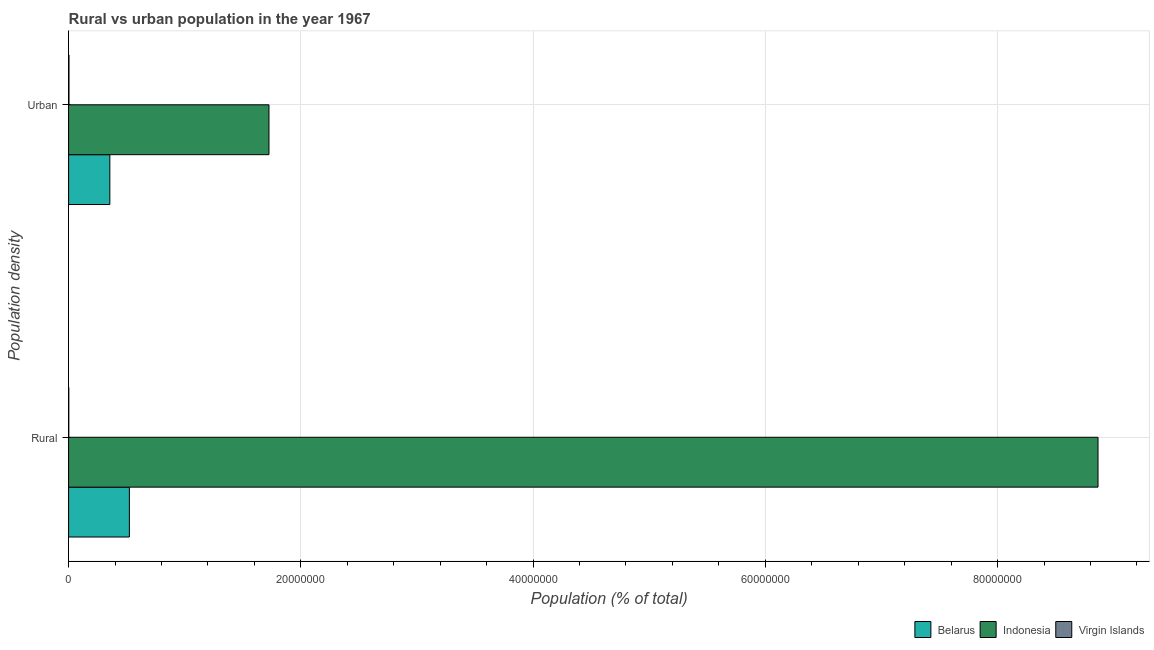How many groups of bars are there?
Keep it short and to the point. 2. Are the number of bars on each tick of the Y-axis equal?
Your answer should be compact. Yes. How many bars are there on the 1st tick from the top?
Provide a short and direct response. 3. What is the label of the 1st group of bars from the top?
Give a very brief answer. Urban. What is the rural population density in Belarus?
Offer a very short reply. 5.23e+06. Across all countries, what is the maximum rural population density?
Offer a very short reply. 8.87e+07. Across all countries, what is the minimum urban population density?
Make the answer very short. 3.35e+04. In which country was the urban population density maximum?
Give a very brief answer. Indonesia. In which country was the rural population density minimum?
Your response must be concise. Virgin Islands. What is the total urban population density in the graph?
Make the answer very short. 2.08e+07. What is the difference between the rural population density in Virgin Islands and that in Indonesia?
Make the answer very short. -8.86e+07. What is the difference between the rural population density in Virgin Islands and the urban population density in Belarus?
Your answer should be very brief. -3.53e+06. What is the average urban population density per country?
Your answer should be compact. 6.95e+06. What is the difference between the urban population density and rural population density in Indonesia?
Offer a terse response. -7.14e+07. In how many countries, is the urban population density greater than 8000000 %?
Provide a succinct answer. 1. What is the ratio of the rural population density in Indonesia to that in Belarus?
Give a very brief answer. 16.94. In how many countries, is the urban population density greater than the average urban population density taken over all countries?
Keep it short and to the point. 1. What does the 1st bar from the top in Rural represents?
Offer a very short reply. Virgin Islands. What does the 2nd bar from the bottom in Urban represents?
Give a very brief answer. Indonesia. Does the graph contain grids?
Offer a very short reply. Yes. How many legend labels are there?
Your answer should be very brief. 3. How are the legend labels stacked?
Give a very brief answer. Horizontal. What is the title of the graph?
Your response must be concise. Rural vs urban population in the year 1967. Does "Eritrea" appear as one of the legend labels in the graph?
Your response must be concise. No. What is the label or title of the X-axis?
Offer a terse response. Population (% of total). What is the label or title of the Y-axis?
Give a very brief answer. Population density. What is the Population (% of total) of Belarus in Rural?
Your response must be concise. 5.23e+06. What is the Population (% of total) of Indonesia in Rural?
Give a very brief answer. 8.87e+07. What is the Population (% of total) of Virgin Islands in Rural?
Provide a short and direct response. 1.73e+04. What is the Population (% of total) of Belarus in Urban?
Keep it short and to the point. 3.55e+06. What is the Population (% of total) in Indonesia in Urban?
Offer a terse response. 1.73e+07. What is the Population (% of total) in Virgin Islands in Urban?
Offer a very short reply. 3.35e+04. Across all Population density, what is the maximum Population (% of total) of Belarus?
Make the answer very short. 5.23e+06. Across all Population density, what is the maximum Population (% of total) of Indonesia?
Your answer should be very brief. 8.87e+07. Across all Population density, what is the maximum Population (% of total) of Virgin Islands?
Provide a succinct answer. 3.35e+04. Across all Population density, what is the minimum Population (% of total) of Belarus?
Provide a short and direct response. 3.55e+06. Across all Population density, what is the minimum Population (% of total) in Indonesia?
Your answer should be compact. 1.73e+07. Across all Population density, what is the minimum Population (% of total) of Virgin Islands?
Provide a succinct answer. 1.73e+04. What is the total Population (% of total) in Belarus in the graph?
Your answer should be very brief. 8.79e+06. What is the total Population (% of total) in Indonesia in the graph?
Your answer should be very brief. 1.06e+08. What is the total Population (% of total) in Virgin Islands in the graph?
Your answer should be compact. 5.08e+04. What is the difference between the Population (% of total) in Belarus in Rural and that in Urban?
Your answer should be very brief. 1.68e+06. What is the difference between the Population (% of total) of Indonesia in Rural and that in Urban?
Your answer should be compact. 7.14e+07. What is the difference between the Population (% of total) of Virgin Islands in Rural and that in Urban?
Make the answer very short. -1.61e+04. What is the difference between the Population (% of total) in Belarus in Rural and the Population (% of total) in Indonesia in Urban?
Give a very brief answer. -1.20e+07. What is the difference between the Population (% of total) of Belarus in Rural and the Population (% of total) of Virgin Islands in Urban?
Your answer should be compact. 5.20e+06. What is the difference between the Population (% of total) in Indonesia in Rural and the Population (% of total) in Virgin Islands in Urban?
Make the answer very short. 8.86e+07. What is the average Population (% of total) in Belarus per Population density?
Provide a short and direct response. 4.39e+06. What is the average Population (% of total) in Indonesia per Population density?
Offer a terse response. 5.30e+07. What is the average Population (% of total) in Virgin Islands per Population density?
Provide a short and direct response. 2.54e+04. What is the difference between the Population (% of total) of Belarus and Population (% of total) of Indonesia in Rural?
Provide a short and direct response. -8.34e+07. What is the difference between the Population (% of total) of Belarus and Population (% of total) of Virgin Islands in Rural?
Keep it short and to the point. 5.22e+06. What is the difference between the Population (% of total) in Indonesia and Population (% of total) in Virgin Islands in Rural?
Provide a short and direct response. 8.86e+07. What is the difference between the Population (% of total) in Belarus and Population (% of total) in Indonesia in Urban?
Offer a terse response. -1.37e+07. What is the difference between the Population (% of total) in Belarus and Population (% of total) in Virgin Islands in Urban?
Ensure brevity in your answer.  3.52e+06. What is the difference between the Population (% of total) of Indonesia and Population (% of total) of Virgin Islands in Urban?
Make the answer very short. 1.72e+07. What is the ratio of the Population (% of total) in Belarus in Rural to that in Urban?
Provide a succinct answer. 1.47. What is the ratio of the Population (% of total) in Indonesia in Rural to that in Urban?
Your answer should be very brief. 5.14. What is the ratio of the Population (% of total) in Virgin Islands in Rural to that in Urban?
Provide a short and direct response. 0.52. What is the difference between the highest and the second highest Population (% of total) of Belarus?
Your answer should be compact. 1.68e+06. What is the difference between the highest and the second highest Population (% of total) in Indonesia?
Make the answer very short. 7.14e+07. What is the difference between the highest and the second highest Population (% of total) of Virgin Islands?
Provide a short and direct response. 1.61e+04. What is the difference between the highest and the lowest Population (% of total) in Belarus?
Your answer should be very brief. 1.68e+06. What is the difference between the highest and the lowest Population (% of total) in Indonesia?
Your answer should be very brief. 7.14e+07. What is the difference between the highest and the lowest Population (% of total) in Virgin Islands?
Make the answer very short. 1.61e+04. 